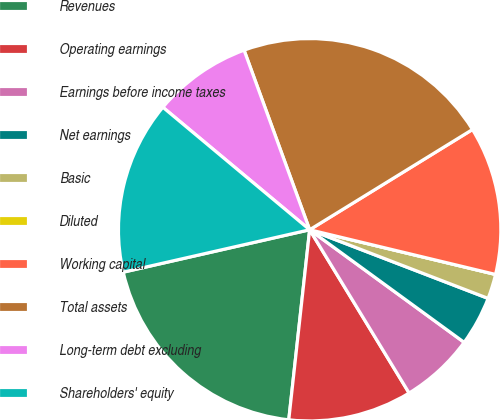<chart> <loc_0><loc_0><loc_500><loc_500><pie_chart><fcel>Revenues<fcel>Operating earnings<fcel>Earnings before income taxes<fcel>Net earnings<fcel>Basic<fcel>Diluted<fcel>Working capital<fcel>Total assets<fcel>Long-term debt excluding<fcel>Shareholders' equity<nl><fcel>19.7%<fcel>10.45%<fcel>6.27%<fcel>4.18%<fcel>2.09%<fcel>0.0%<fcel>12.54%<fcel>21.79%<fcel>8.36%<fcel>14.63%<nl></chart> 